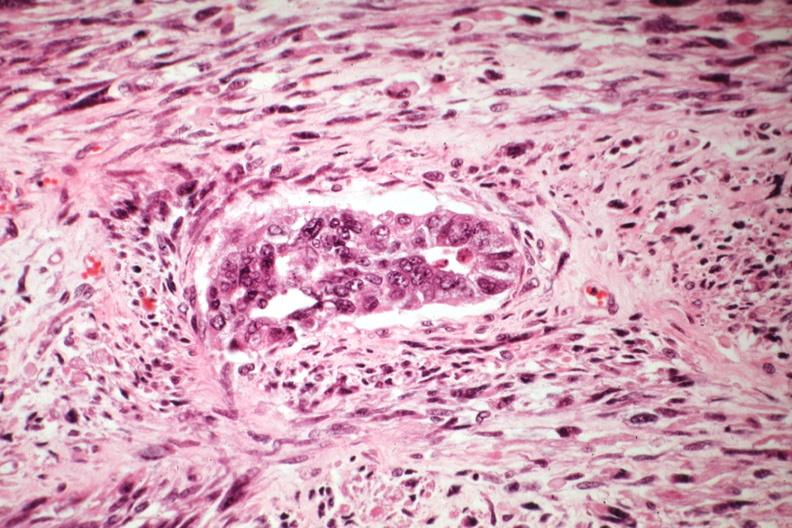does this image show malignant gland and stoma?
Answer the question using a single word or phrase. Yes 